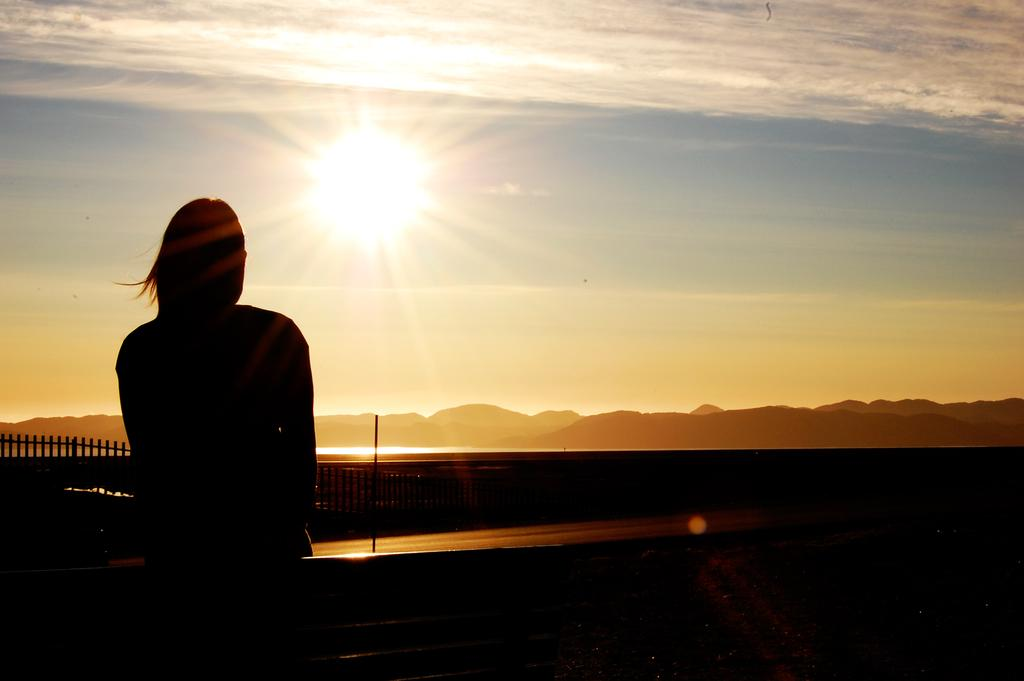Who is on the left side of the image? There is a lady on the left side of the image. What can be seen in the background of the image? There is a fence, hills, and the sky visible in the background of the image. What is the main celestial body visible in the image? The sun is visible in the center of the image. What do the pigs smell like in the image? There are no pigs present in the image, so it is not possible to determine what they might smell like. 